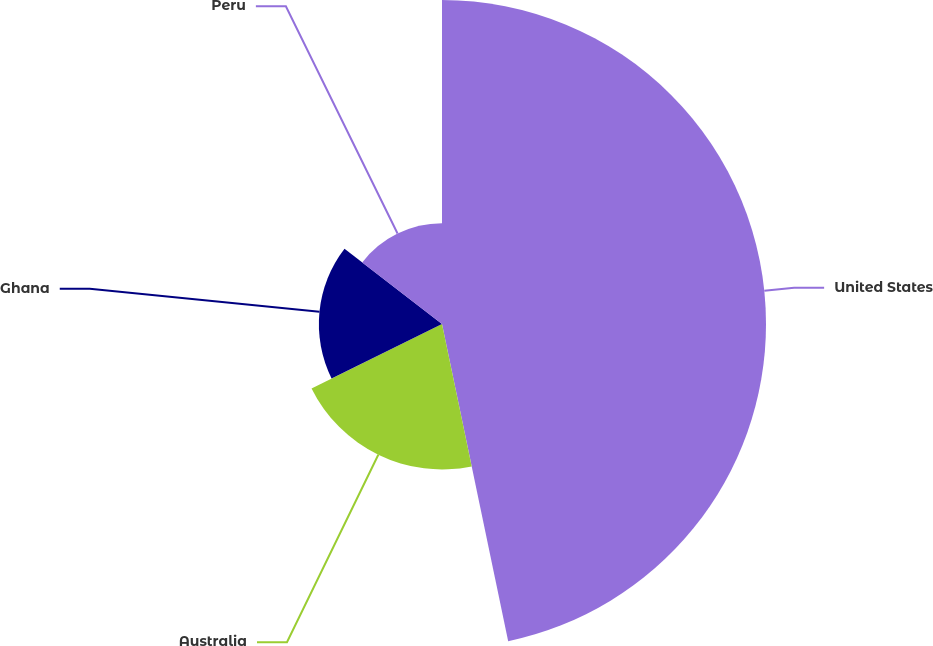<chart> <loc_0><loc_0><loc_500><loc_500><pie_chart><fcel>United States<fcel>Australia<fcel>Ghana<fcel>Peru<nl><fcel>46.73%<fcel>20.98%<fcel>17.76%<fcel>14.54%<nl></chart> 